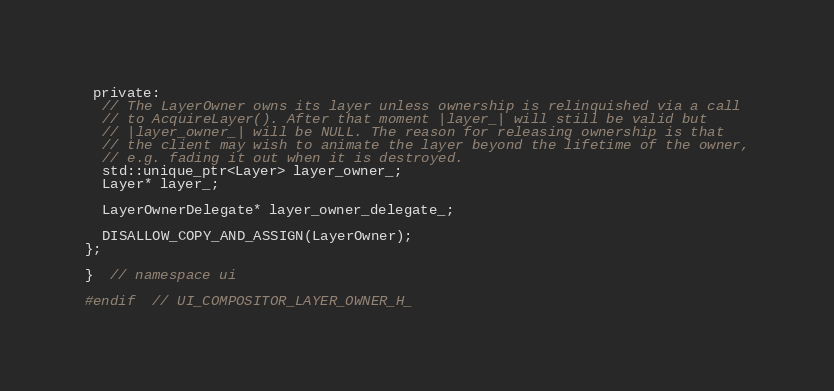Convert code to text. <code><loc_0><loc_0><loc_500><loc_500><_C_>
 private:
  // The LayerOwner owns its layer unless ownership is relinquished via a call
  // to AcquireLayer(). After that moment |layer_| will still be valid but
  // |layer_owner_| will be NULL. The reason for releasing ownership is that
  // the client may wish to animate the layer beyond the lifetime of the owner,
  // e.g. fading it out when it is destroyed.
  std::unique_ptr<Layer> layer_owner_;
  Layer* layer_;

  LayerOwnerDelegate* layer_owner_delegate_;

  DISALLOW_COPY_AND_ASSIGN(LayerOwner);
};

}  // namespace ui

#endif  // UI_COMPOSITOR_LAYER_OWNER_H_
</code> 